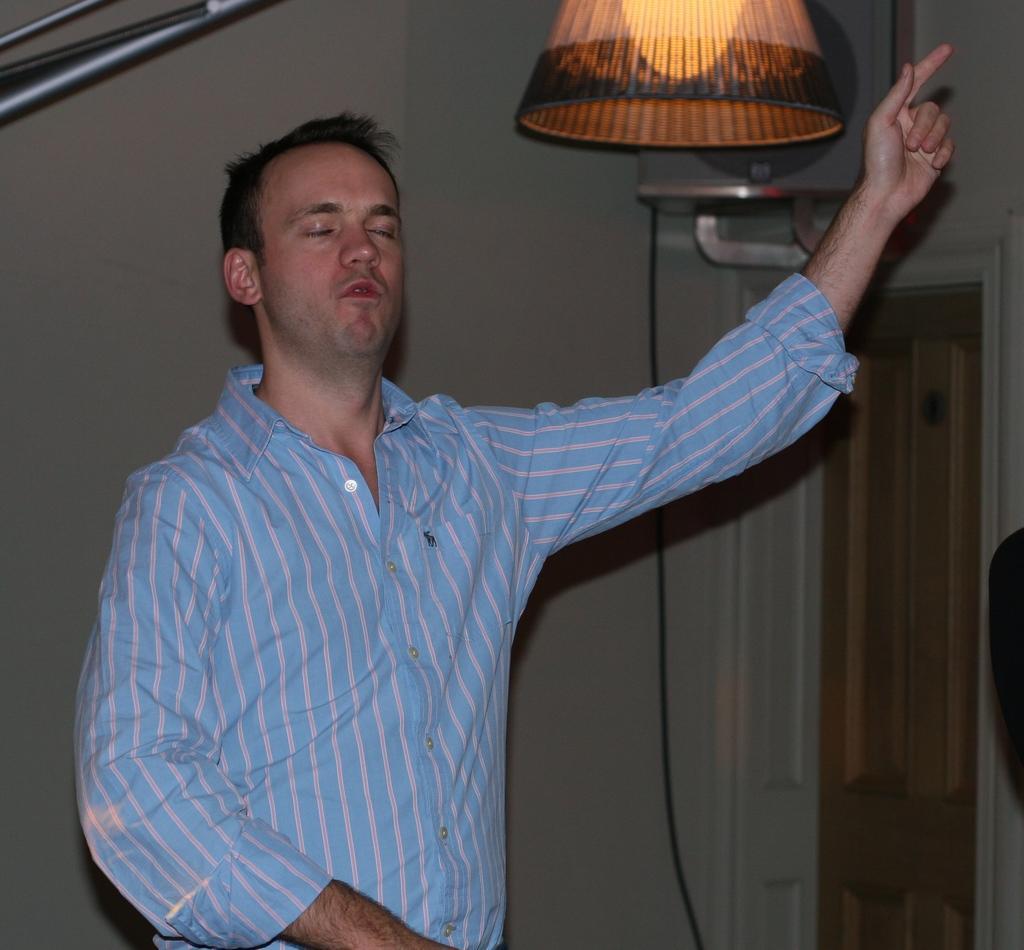Please provide a concise description of this image. In the center of the picture there is a man in blue shirt. At the top there is a lamp. Behind him it is well. On the right there are door, cable another object. 